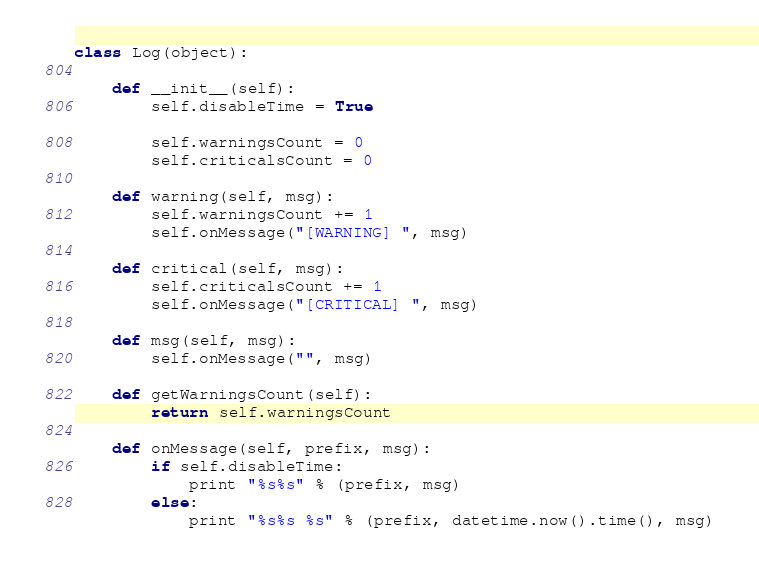<code> <loc_0><loc_0><loc_500><loc_500><_Python_>class Log(object):

	def __init__(self):
		self.disableTime = True

		self.warningsCount = 0
		self.criticalsCount = 0

	def warning(self, msg):
		self.warningsCount += 1
		self.onMessage("[WARNING] ", msg)

	def critical(self, msg):
		self.criticalsCount += 1
		self.onMessage("[CRITICAL] ", msg)

	def msg(self, msg):
		self.onMessage("", msg)

	def getWarningsCount(self):
		return self.warningsCount

	def onMessage(self, prefix, msg):
		if self.disableTime:
			print "%s%s" % (prefix, msg)
		else:
			print "%s%s %s" % (prefix, datetime.now().time(), msg)</code> 